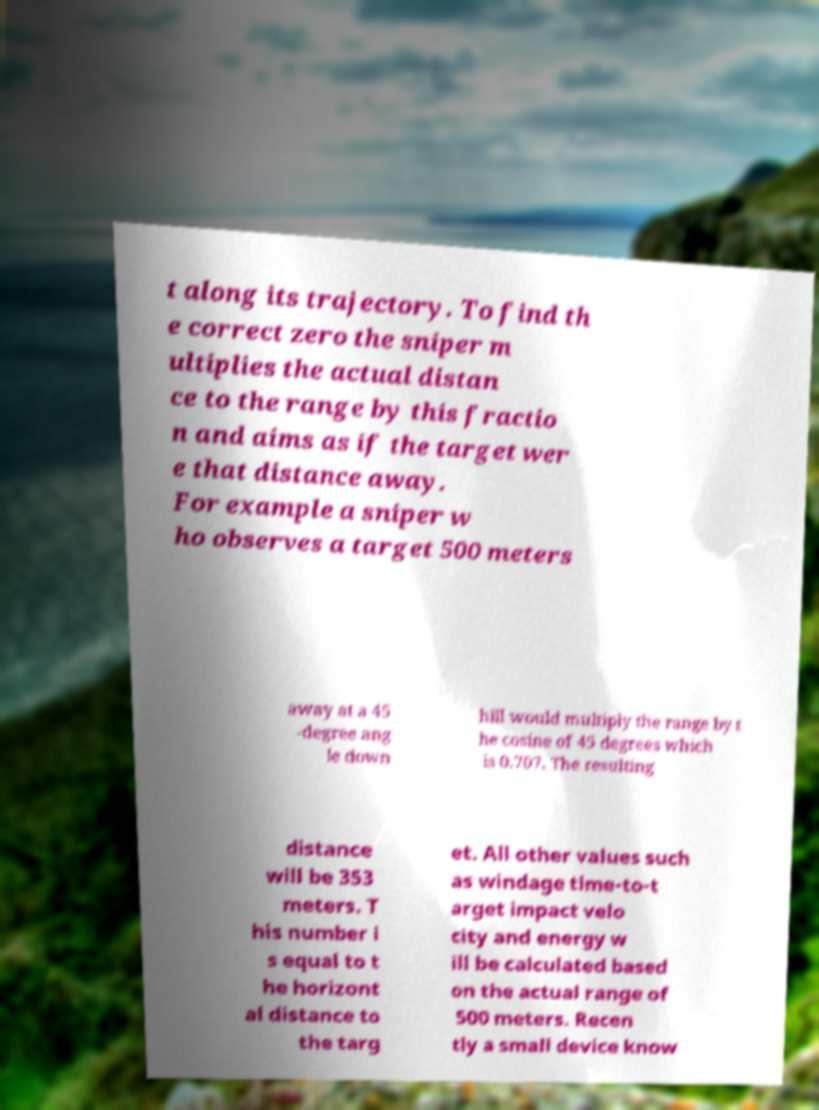Could you extract and type out the text from this image? t along its trajectory. To find th e correct zero the sniper m ultiplies the actual distan ce to the range by this fractio n and aims as if the target wer e that distance away. For example a sniper w ho observes a target 500 meters away at a 45 -degree ang le down hill would multiply the range by t he cosine of 45 degrees which is 0.707. The resulting distance will be 353 meters. T his number i s equal to t he horizont al distance to the targ et. All other values such as windage time-to-t arget impact velo city and energy w ill be calculated based on the actual range of 500 meters. Recen tly a small device know 